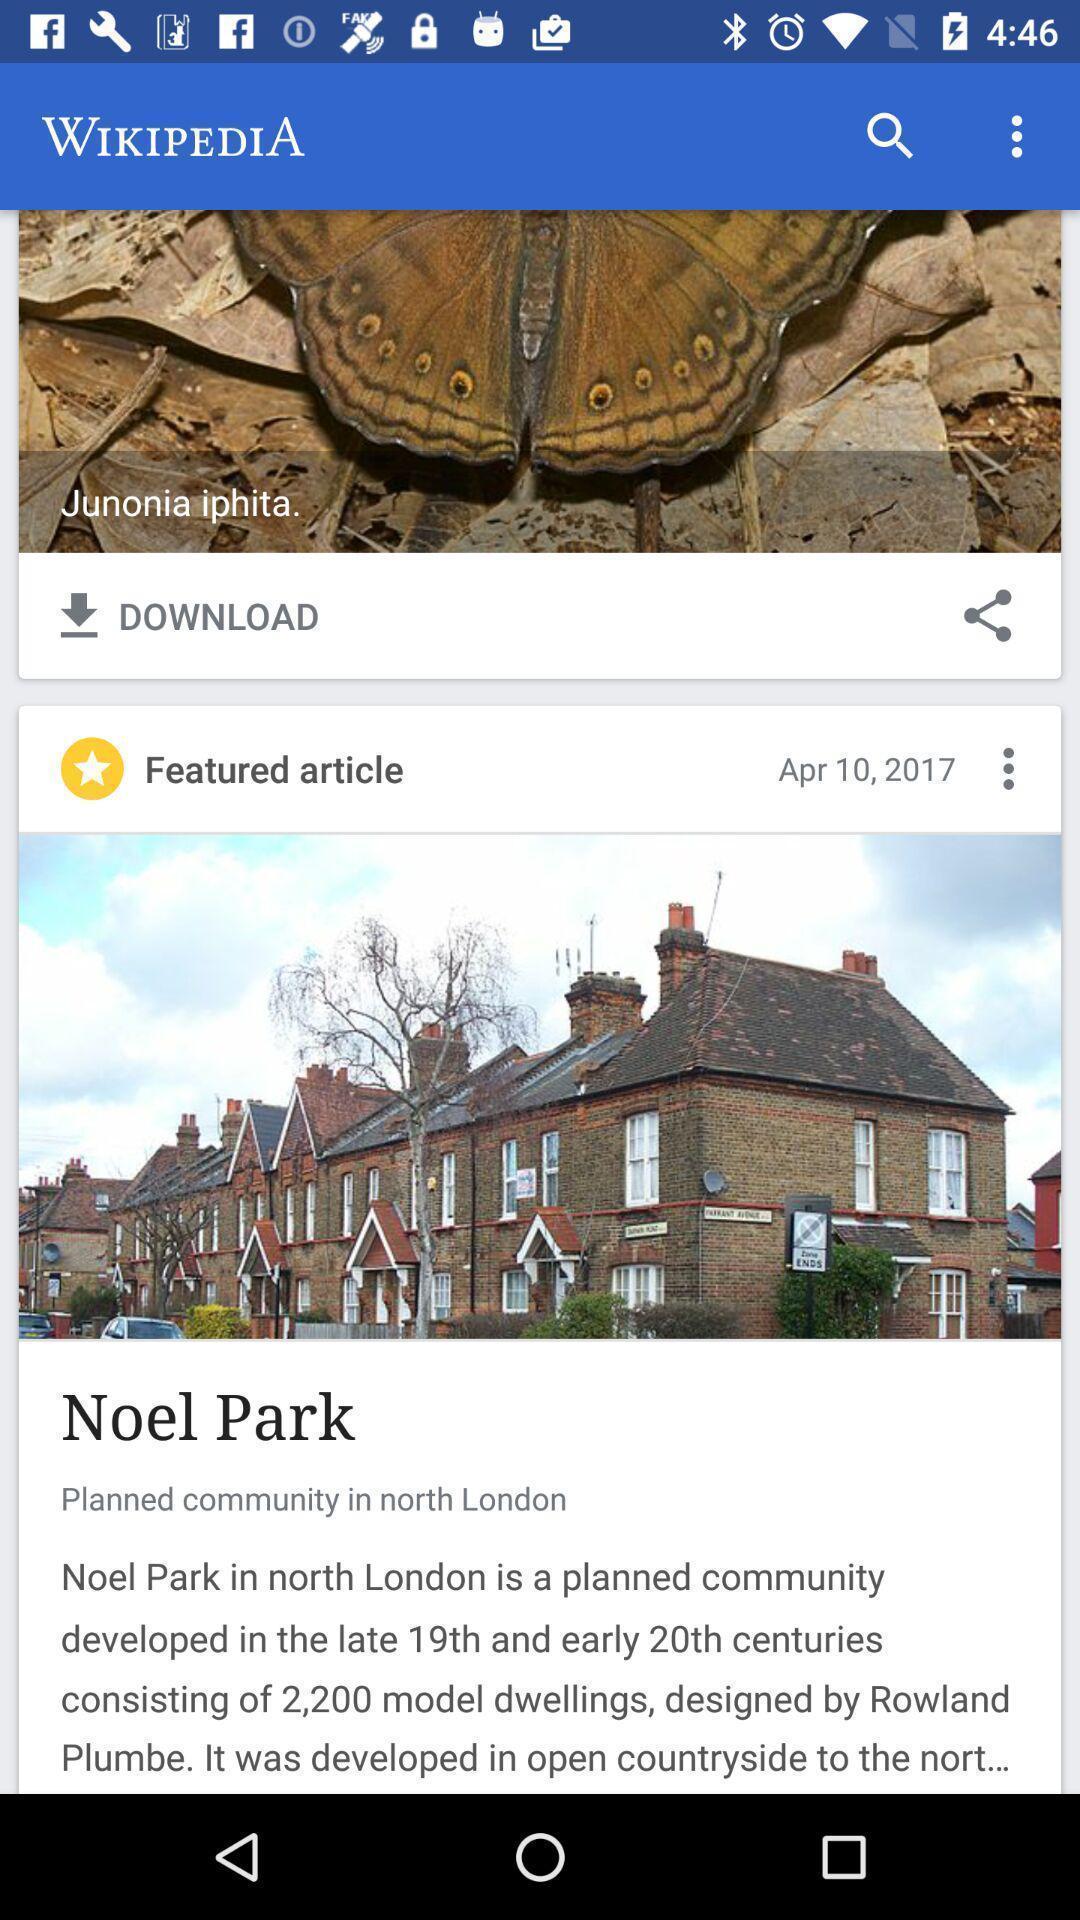Explain the elements present in this screenshot. Screen displaying wikipedia page. 